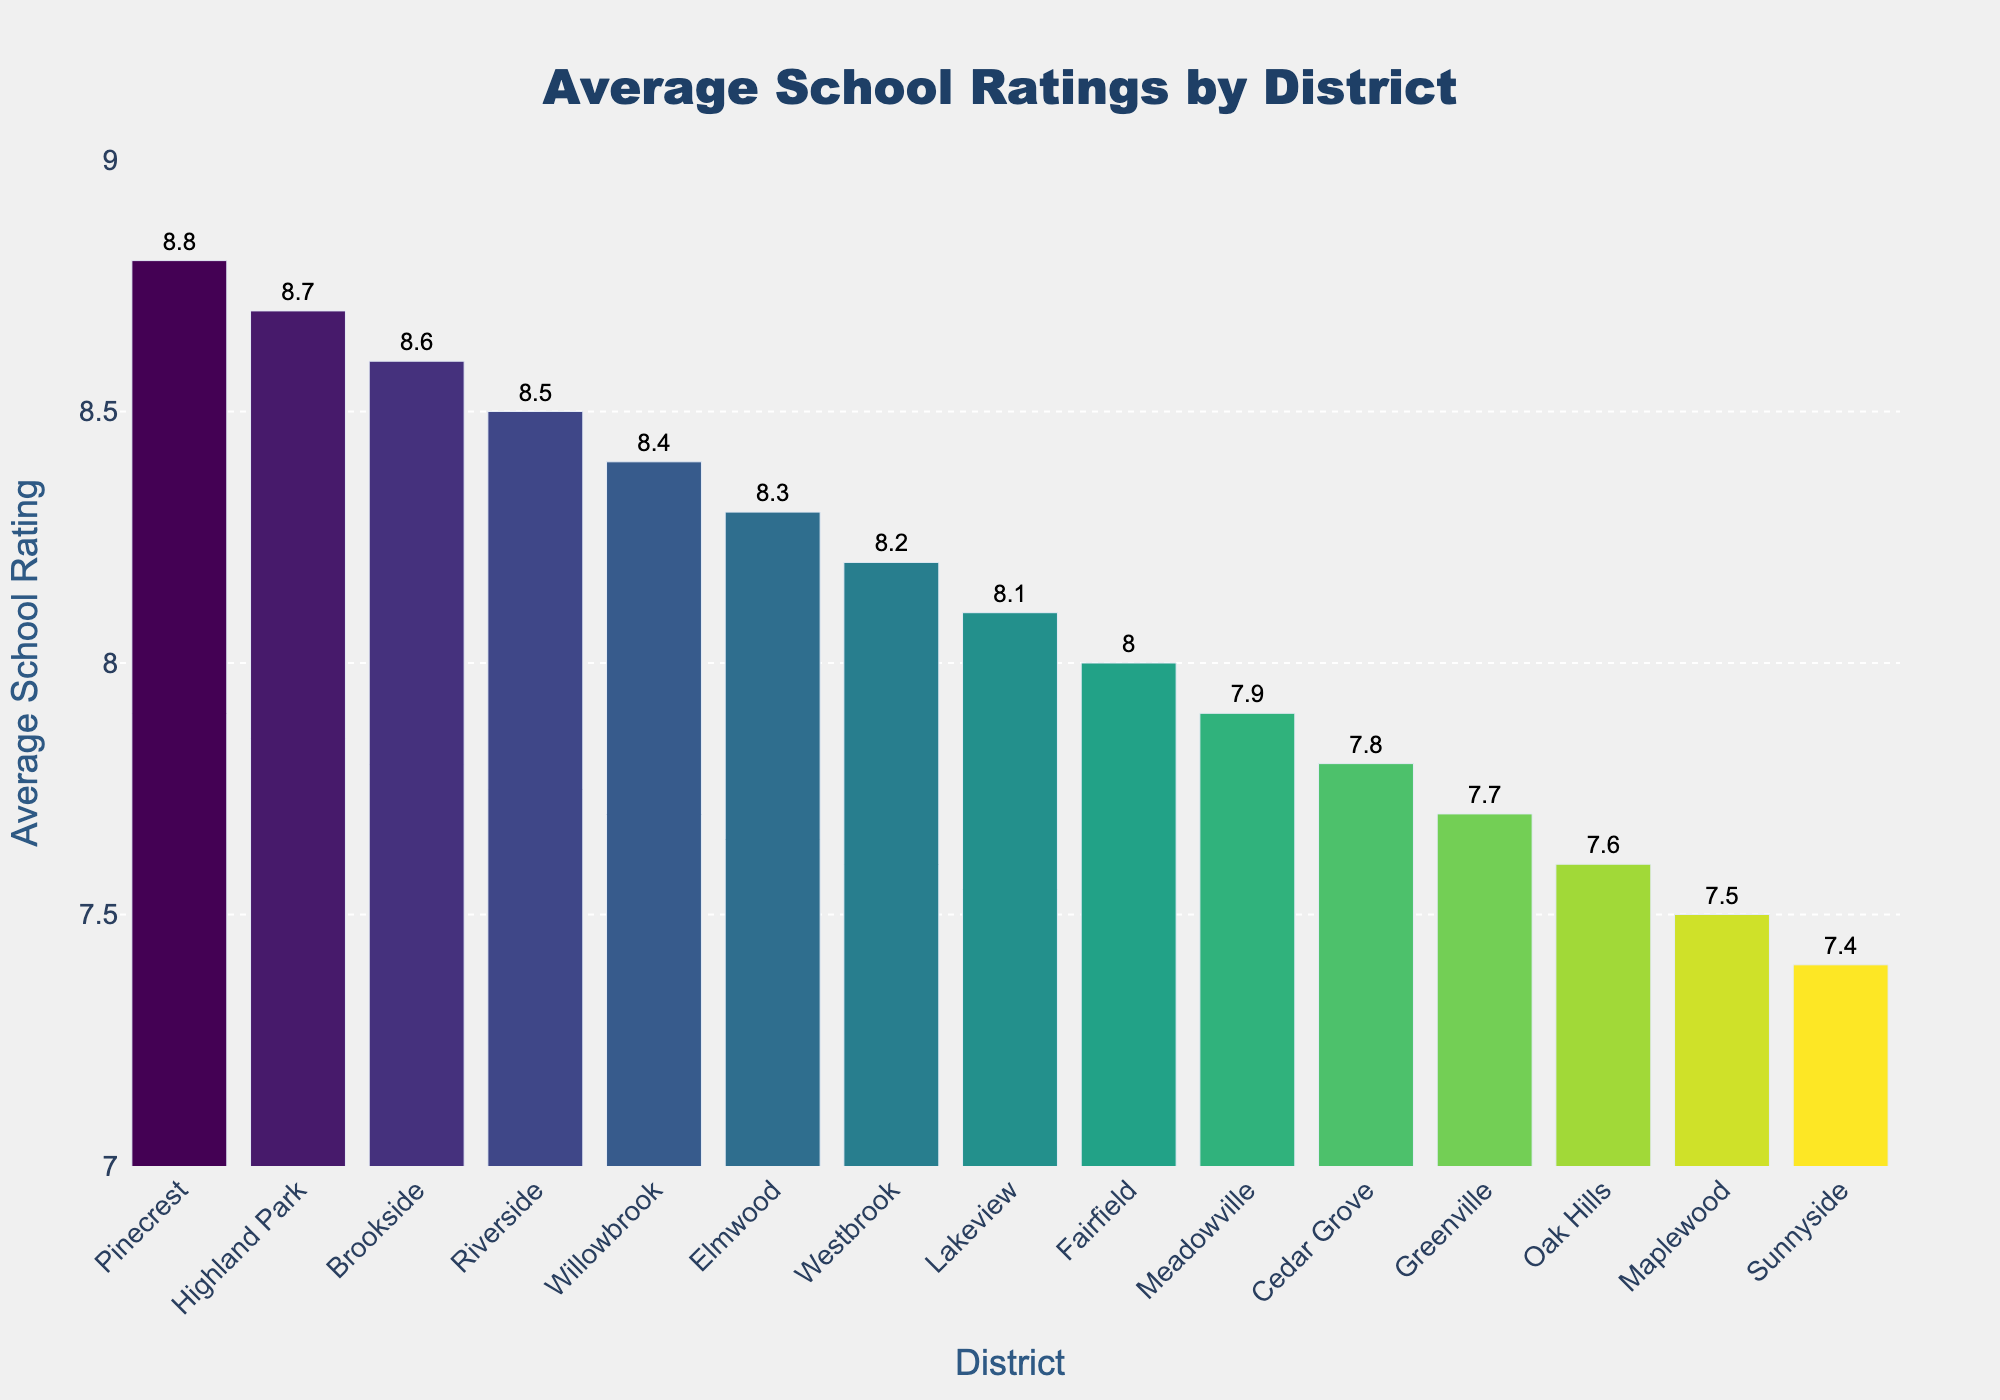Which district has the highest average school rating? The highest bar in the chart represents Pinecrest with an average school rating of 8.8.
Answer: Pinecrest Which district has the lowest average school rating? The lowest bar in the chart represents Sunnyside with an average school rating of 7.4.
Answer: Sunnyside How many districts have an average school rating above 8.0? Identify all bars that reach above the 8.0 line: Westbrook, Riverside, Pinecrest, Highland Park, Elmwood, Lakeview, Willowbrook, and Brookside.
Answer: 8 Which districts have a school rating between 8.0 and 8.5? Identify the bars between 8.0 and 8.5: Westbrook, Elmwood, Lakeview, Fairfield, Willowbrook, Westbrook
Answer: 6 What is the difference in average school rating between the top and bottom districts? Pinecrest has the highest rating of 8.8 and Sunnyside has the lowest rating of 7.4. The difference is 8.8 - 7.4.
Answer: 1.4 What is the median school rating of all the districts? Arrange all ratings in ascending order: 7.4, 7.5, 7.6, 7.7, 7.8, 7.9, 8.0, 8.1, 8.2, 8.3, 8.4, 8.5, 8.6, 8.7, 8.8. The median is the middle value in this ordered list, which is 8.1.
Answer: 8.1 Which district has the second-highest school rating and what is it? The second highest bar represents Highland Park with an average school rating of 8.7.
Answer: Highland Park What is the average school rating across all districts? Sum all the ratings: 8.2 + 7.9 + 8.5 + 7.6 + 8.8 + 7.4 + 8.1 + 8.7 + 7.8 + 8.3 + 7.5 + 8.6 + 8.0 + 7.7 + 8.4 = 121.5. There are 15 districts, so the average rating is 121.5 / 15.
Answer: 8.1 How many districts have ratings equal to or below the average rating of all districts? The calculated average is 8.1. Count the bars that are at or below this rating: Meadowville, Oak Hills, Sunnyside, Cedar Grove, Maplewood, Fairfield, Greenville, Lakeview
Answer: 8 